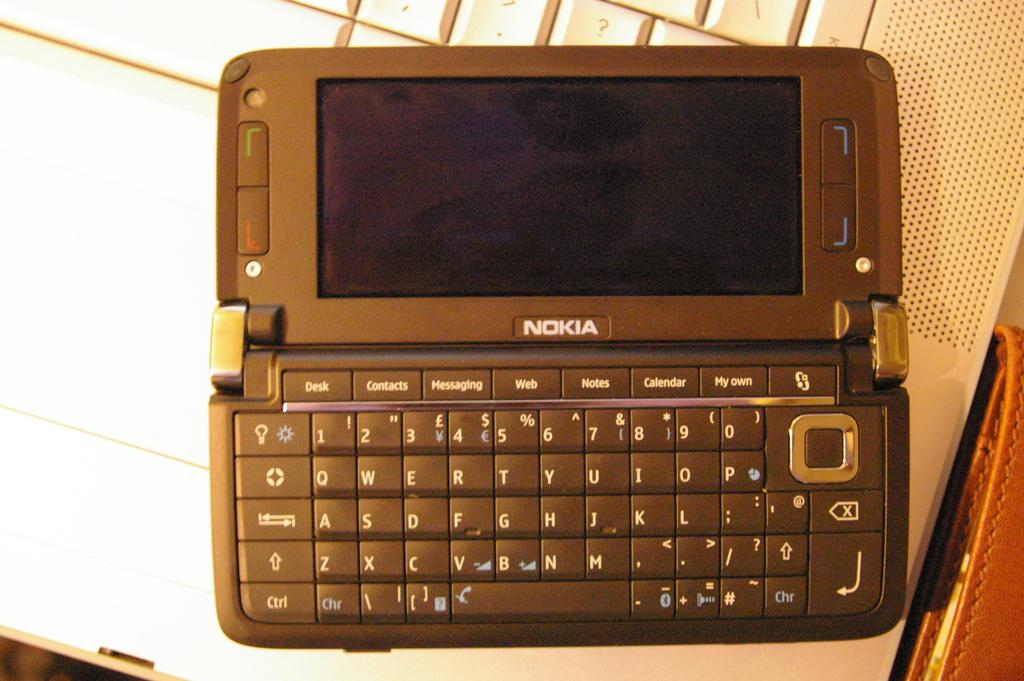<image>
Write a terse but informative summary of the picture. Phone with a keyboard and the word NOKIA on it. 